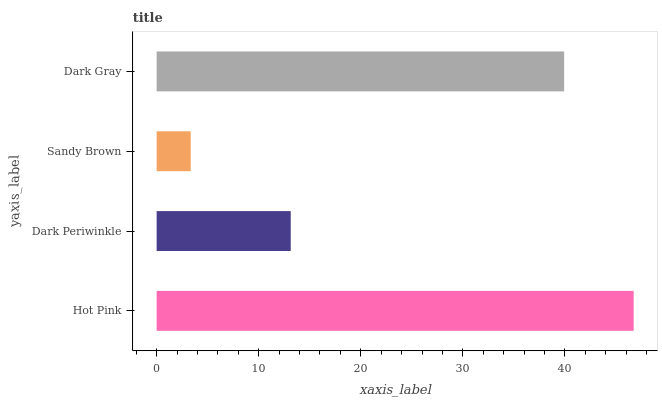Is Sandy Brown the minimum?
Answer yes or no. Yes. Is Hot Pink the maximum?
Answer yes or no. Yes. Is Dark Periwinkle the minimum?
Answer yes or no. No. Is Dark Periwinkle the maximum?
Answer yes or no. No. Is Hot Pink greater than Dark Periwinkle?
Answer yes or no. Yes. Is Dark Periwinkle less than Hot Pink?
Answer yes or no. Yes. Is Dark Periwinkle greater than Hot Pink?
Answer yes or no. No. Is Hot Pink less than Dark Periwinkle?
Answer yes or no. No. Is Dark Gray the high median?
Answer yes or no. Yes. Is Dark Periwinkle the low median?
Answer yes or no. Yes. Is Hot Pink the high median?
Answer yes or no. No. Is Sandy Brown the low median?
Answer yes or no. No. 